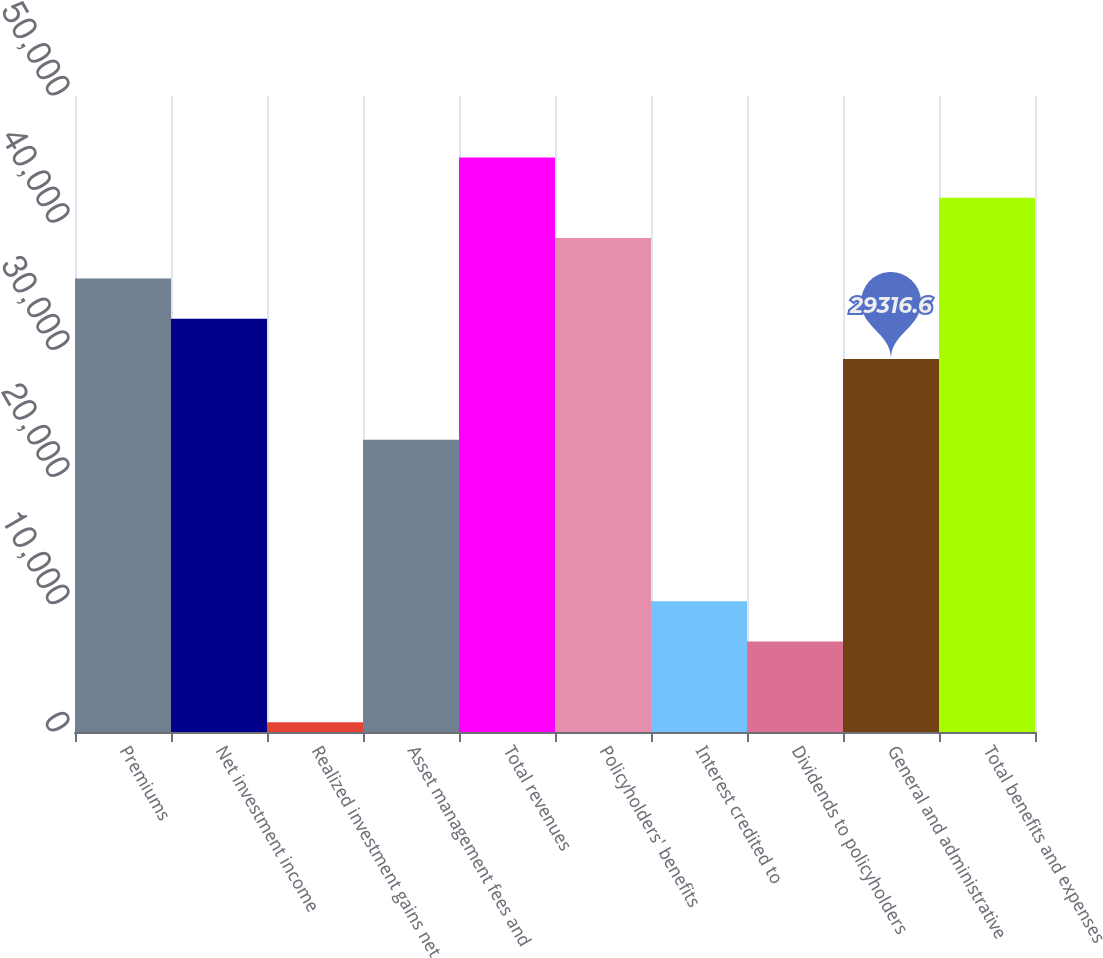Convert chart to OTSL. <chart><loc_0><loc_0><loc_500><loc_500><bar_chart><fcel>Premiums<fcel>Net investment income<fcel>Realized investment gains net<fcel>Asset management fees and<fcel>Total revenues<fcel>Policyholders' benefits<fcel>Interest credited to<fcel>Dividends to policyholders<fcel>General and administrative<fcel>Total benefits and expenses<nl><fcel>35659.4<fcel>32488<fcel>774<fcel>22973.8<fcel>45173.6<fcel>38830.8<fcel>10288.2<fcel>7116.8<fcel>29316.6<fcel>42002.2<nl></chart> 